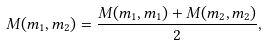<formula> <loc_0><loc_0><loc_500><loc_500>M ( m _ { 1 } , m _ { 2 } ) = \frac { M ( m _ { 1 } , m _ { 1 } ) + M ( m _ { 2 } , m _ { 2 } ) } { 2 } ,</formula> 